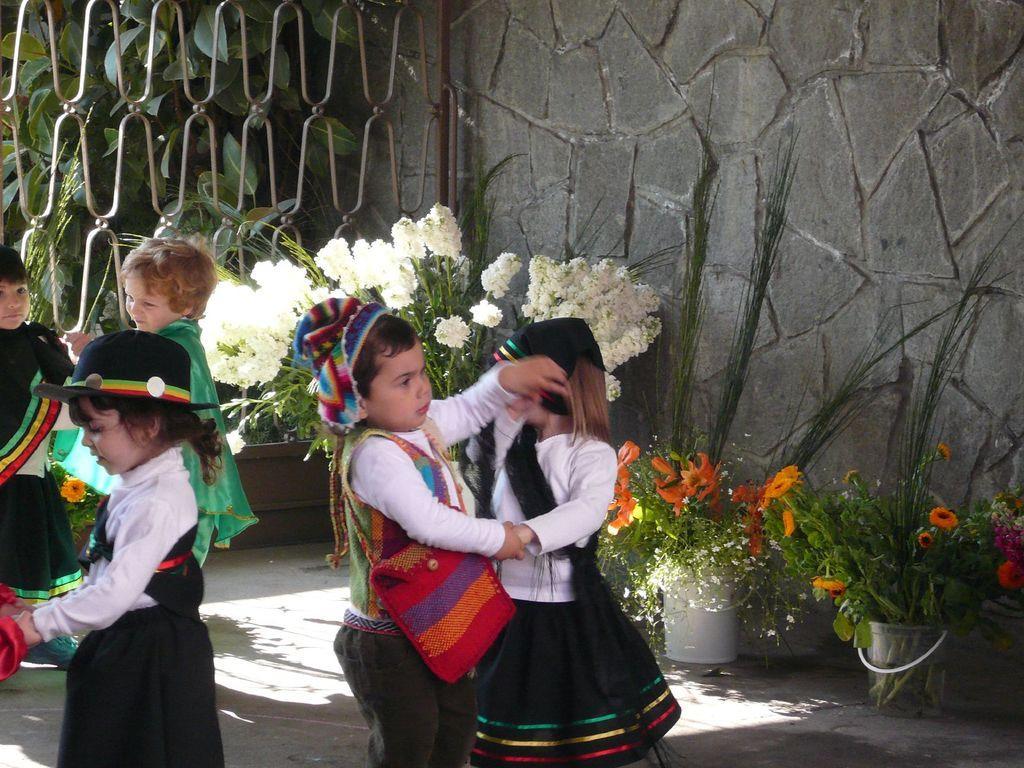How would you summarize this image in a sentence or two? In the image in the center, we can see a few kids are dancing and they are in different costumes. In the background there is a wall, fence, trees, plants, plant pots and flowers. 